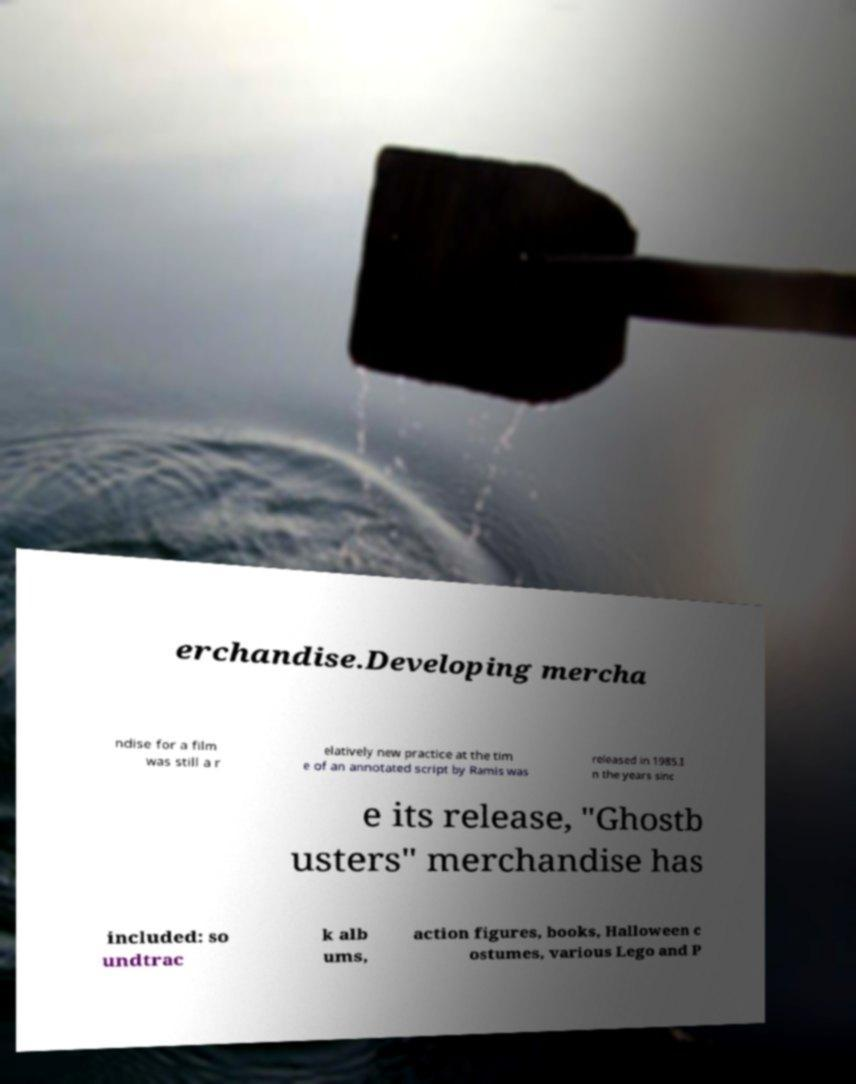Can you accurately transcribe the text from the provided image for me? erchandise.Developing mercha ndise for a film was still a r elatively new practice at the tim e of an annotated script by Ramis was released in 1985.I n the years sinc e its release, "Ghostb usters" merchandise has included: so undtrac k alb ums, action figures, books, Halloween c ostumes, various Lego and P 